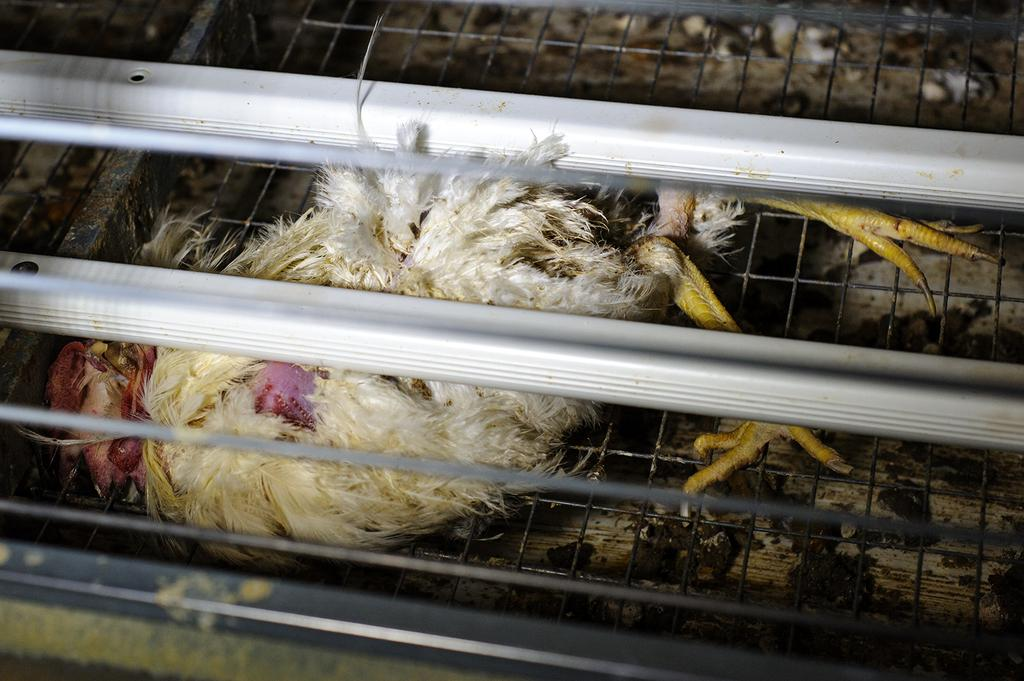What type of animal is present in the image? There is a hen in the image. Can you describe the surface on which the hen is standing? The hen is on a metal grill. What other metal objects can be seen in the image? There are metal rods in the image. How many boats can be seen in the image? There are no boats present in the image. What type of bell is hanging from the metal rods in the image? There is no bell hanging from the metal rods in the image. 